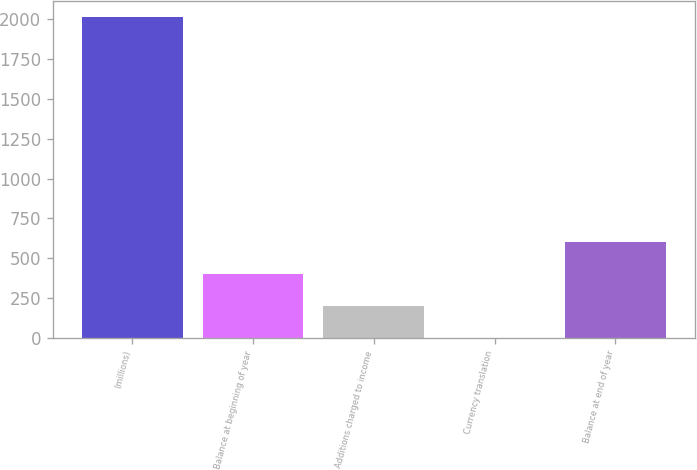Convert chart. <chart><loc_0><loc_0><loc_500><loc_500><bar_chart><fcel>(millions)<fcel>Balance at beginning of year<fcel>Additions charged to income<fcel>Currency translation<fcel>Balance at end of year<nl><fcel>2012<fcel>403.2<fcel>202.1<fcel>1<fcel>604.3<nl></chart> 